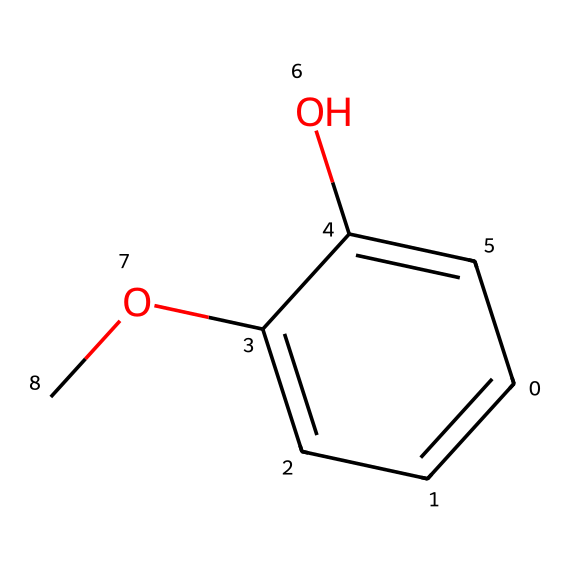What is the basic structure of this chemical? The chemical has a phenolic structure with a methoxy group. The phenolic structure indicates the presence of a benzene ring with a hydroxyl group, and the methoxy group is attached to this structure, thus giving it a specific configuration.
Answer: phenolic structure How many oxygen atoms are present in this chemical? The provided SMILES indicates two oxygen atoms: one in the hydroxyl group (OH) and another in the methoxy group (OCH3). By examining the structure represented in the SMILES, we can count both oxygen atoms.
Answer: two What chemical groups are present in this compound? This compound contains a hydroxyl (-OH) group and a methoxy (-OCH3) group. The aromatic ring along with these functional groups shows that it is an ether and alcohol derivative.
Answer: hydroxyl and methoxy groups What type of bonding is primarily found in this chemical? The SMILES reveals primarily covalent bonds, evidenced by the connections between carbon, oxygen, and hydrogen within the structure. Since these elements share electrons, it indicates covalent bonding dominance.
Answer: covalent bonds What flavor profile might this chemical contribute to Scotch whisky? The presence of a phenolic structure often contributes to smoky, earthy, and sometimes medicinal flavors in whisky, particularly from peat smoke during production. The complex interactions of functional groups influence the aromatic profile.
Answer: smoky Why might the methoxy group affect the aroma of whisky? The methoxy group can enhance the sweetness and complexity of the aroma; its presence modifies the interaction of the compound with other aromatic compounds, thus influencing the overall scent in the whisky.
Answer: sweetness and complexity 